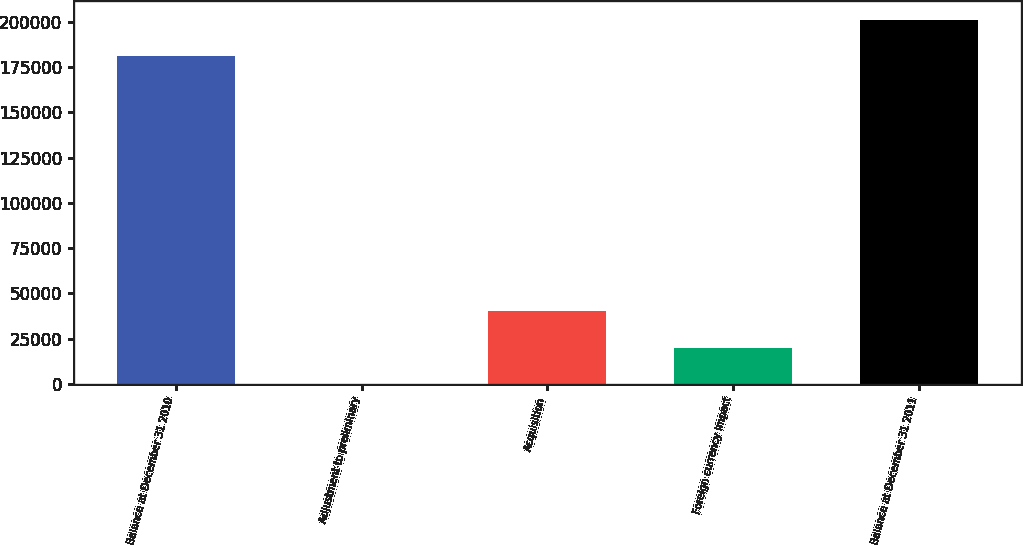<chart> <loc_0><loc_0><loc_500><loc_500><bar_chart><fcel>Balance at December 31 2010<fcel>Adjustment to preliminary<fcel>Acquisition<fcel>Foreign currency impact<fcel>Balance at December 31 2011<nl><fcel>181228<fcel>238<fcel>40052.4<fcel>20145.2<fcel>201135<nl></chart> 